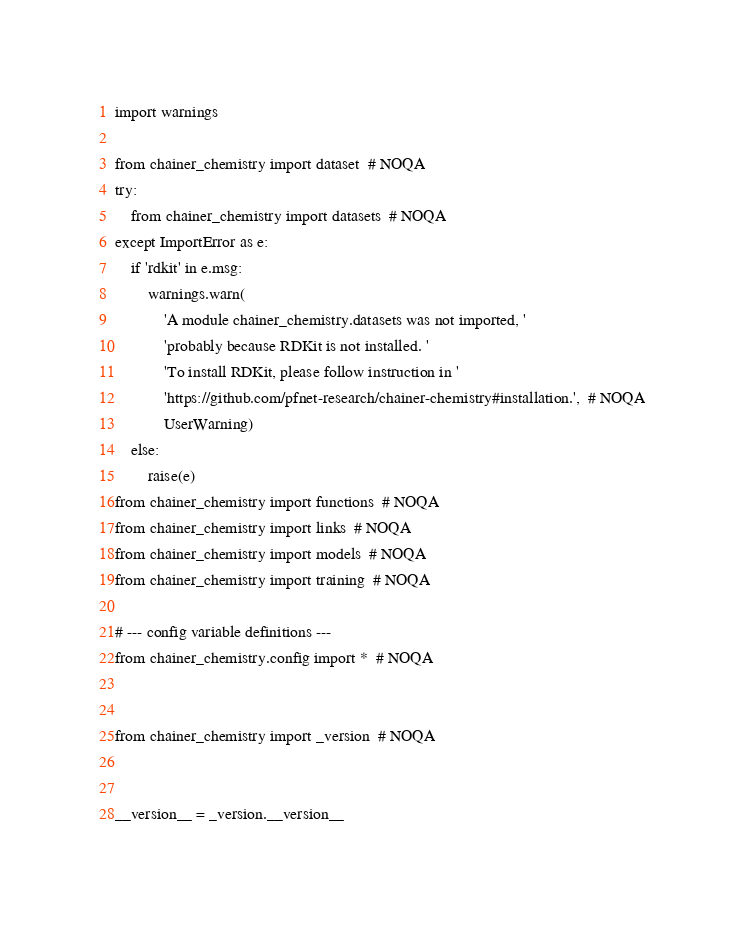Convert code to text. <code><loc_0><loc_0><loc_500><loc_500><_Python_>import warnings

from chainer_chemistry import dataset  # NOQA
try:
    from chainer_chemistry import datasets  # NOQA
except ImportError as e:
    if 'rdkit' in e.msg:
        warnings.warn(
            'A module chainer_chemistry.datasets was not imported, '
            'probably because RDKit is not installed. '
            'To install RDKit, please follow instruction in '
            'https://github.com/pfnet-research/chainer-chemistry#installation.',  # NOQA
            UserWarning)
    else:
        raise(e)
from chainer_chemistry import functions  # NOQA
from chainer_chemistry import links  # NOQA
from chainer_chemistry import models  # NOQA
from chainer_chemistry import training  # NOQA

# --- config variable definitions ---
from chainer_chemistry.config import *  # NOQA


from chainer_chemistry import _version  # NOQA


__version__ = _version.__version__
</code> 